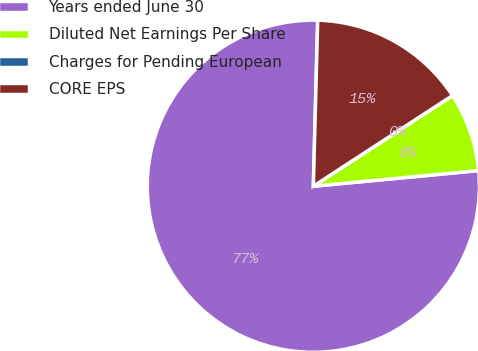Convert chart to OTSL. <chart><loc_0><loc_0><loc_500><loc_500><pie_chart><fcel>Years ended June 30<fcel>Diluted Net Earnings Per Share<fcel>Charges for Pending European<fcel>CORE EPS<nl><fcel>76.92%<fcel>7.69%<fcel>0.0%<fcel>15.39%<nl></chart> 